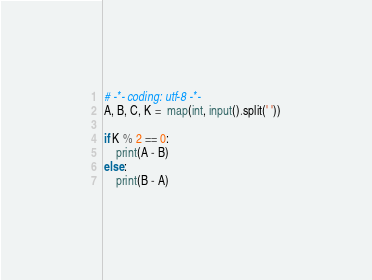<code> <loc_0><loc_0><loc_500><loc_500><_Python_># -*- coding: utf-8 -*-
A, B, C, K =  map(int, input().split(' '))

if K % 2 == 0:
    print(A - B)
else:
    print(B - A)</code> 